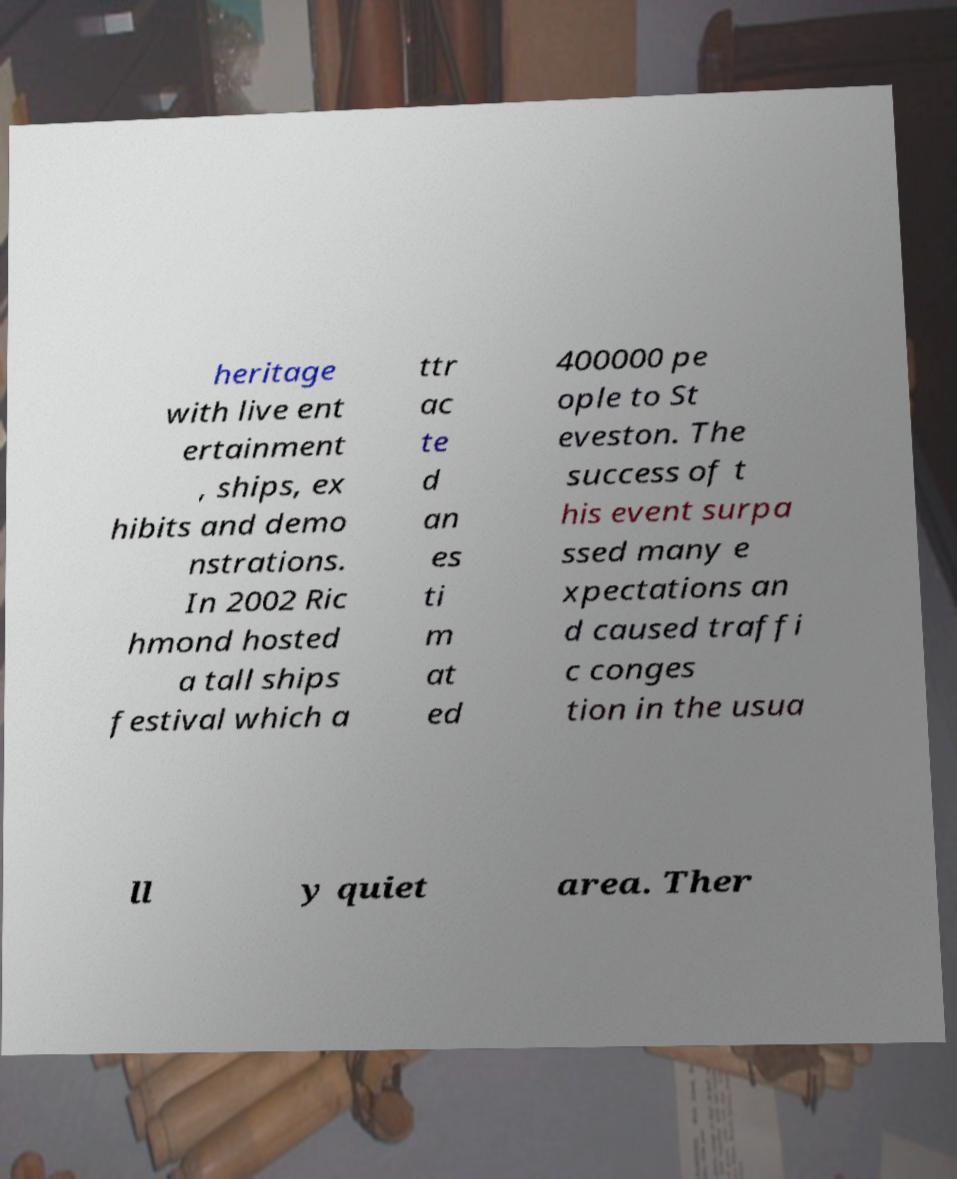Can you read and provide the text displayed in the image?This photo seems to have some interesting text. Can you extract and type it out for me? heritage with live ent ertainment , ships, ex hibits and demo nstrations. In 2002 Ric hmond hosted a tall ships festival which a ttr ac te d an es ti m at ed 400000 pe ople to St eveston. The success of t his event surpa ssed many e xpectations an d caused traffi c conges tion in the usua ll y quiet area. Ther 